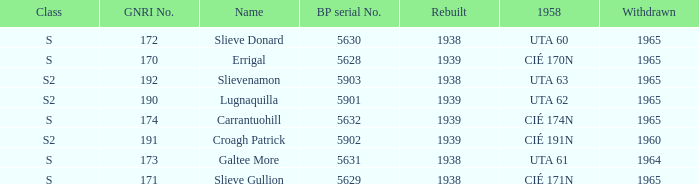What is the smallest withdrawn value with a GNRI greater than 172, name of Croagh Patrick and was rebuilt before 1939? None. 